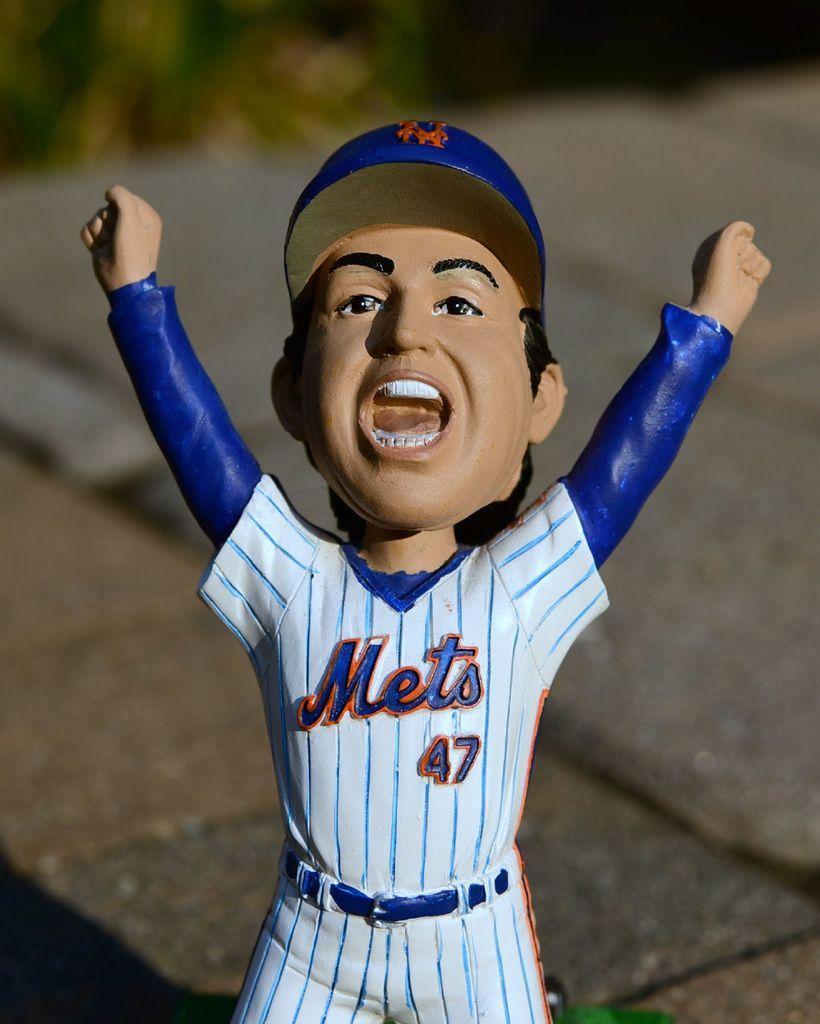What is the jersey number of this mets player?
Keep it short and to the point. 47. What team is on the jersey?
Your answer should be very brief. Mets. 